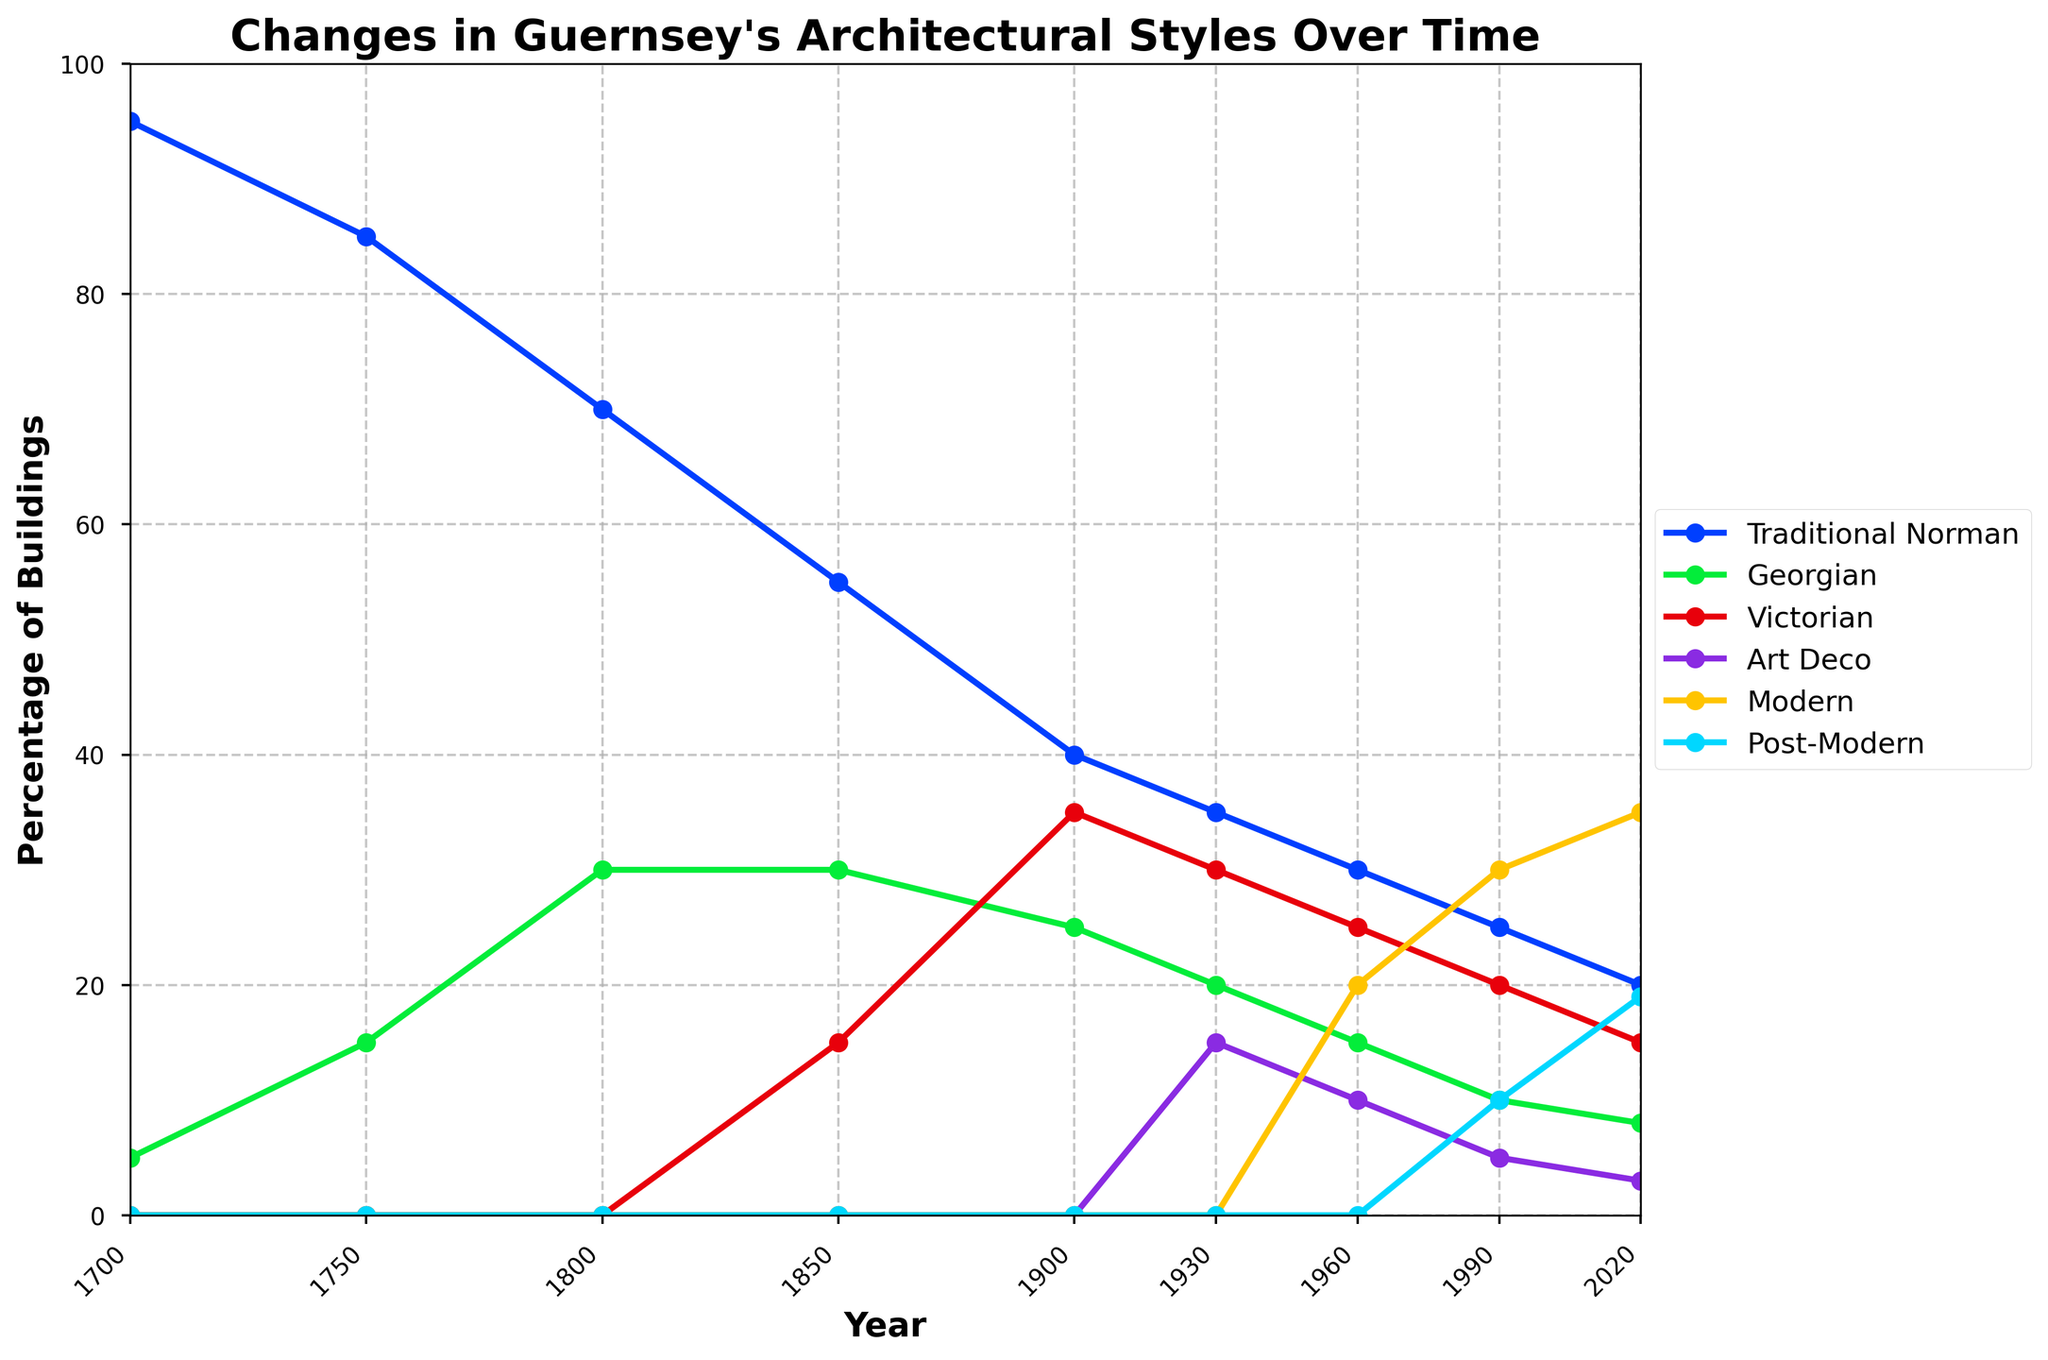What percentage of buildings were Traditional Norman in 1750? The graph's Traditional Norman line at the year 1750 shows around 85%, so the percentage of Traditional Norman buildings is 85%
Answer: 85% Which architectural style shows a steady increase in percentage from 1960 to 2020? Observing the trends from 1960 to 2020, the Modern style continually increases from 20% to 35% over the period
Answer: Modern How did the percentage of Art Deco buildings change between 1930 and 1990? The graph shows that the percentage of Art Deco buildings goes from 15% in 1930 down to 5% in 1990, a decrease of 10%
Answer: Decreased by 10% Which architectural style had the highest percentage in 1900? Referencing the graph in 1900, Traditional Norman maintains the highest percentage among the architectural styles at around 40%
Answer: Traditional Norman Calculate the average percentage of Victorian buildings from 1850 to 2020. Summing the percentages of Victorian buildings from 1850 (15%), 1900 (35%), 1930 (30%), 1960 (25%), 1990 (20%), and 2020 (15%), which equals 140%. Dividing by the number of data points (6) results in the average percentage of 23.33%
Answer: 23.33% What is the difference in percentage of Georgian and Post-Modern buildings in 1990? The graph shows the percentages of Georgian and Post-Modern buildings in 1990 at around 10% and 10%, respectively. 10% - 10% = 0%
Answer: 0% Which architectural style surpassed Traditional Norman in percentage first, and in which year? Victorian style surpassed Traditional Norman first in 1900. It registers 35% compared to Traditional Norman's 40%, followed by 25% for Georgian va 40% of Traditional Norman's buildings
Answer: Victorian, 1900 Is there a year when the percentage of Modern buildings was twice that of Art Deco buildings? In 2020, the percentage of Modern buildings is 35% and the percentage of Art Deco buildings is 3%. 35% is very close to 3% * 2 = 6%, confirming the year as 2020
Answer: 2020 What was the combined percentage of Georgian and Victorian buildings in 1800? The graph indicates the percentage of Georgian buildings in 1800 as 30% and 0% for Victorian buildings. Summing these gives 30% + 0% = 30%
Answer: 30% In which period did the Traditional Norman style experience the most significant decline in percentage? Review the graph data for Traditional Norman style; the largest decrease between two adjacent periods occurs from 1700 to 1750, dropping 95% to 85% by 10%
Answer: 1700 to 1750 